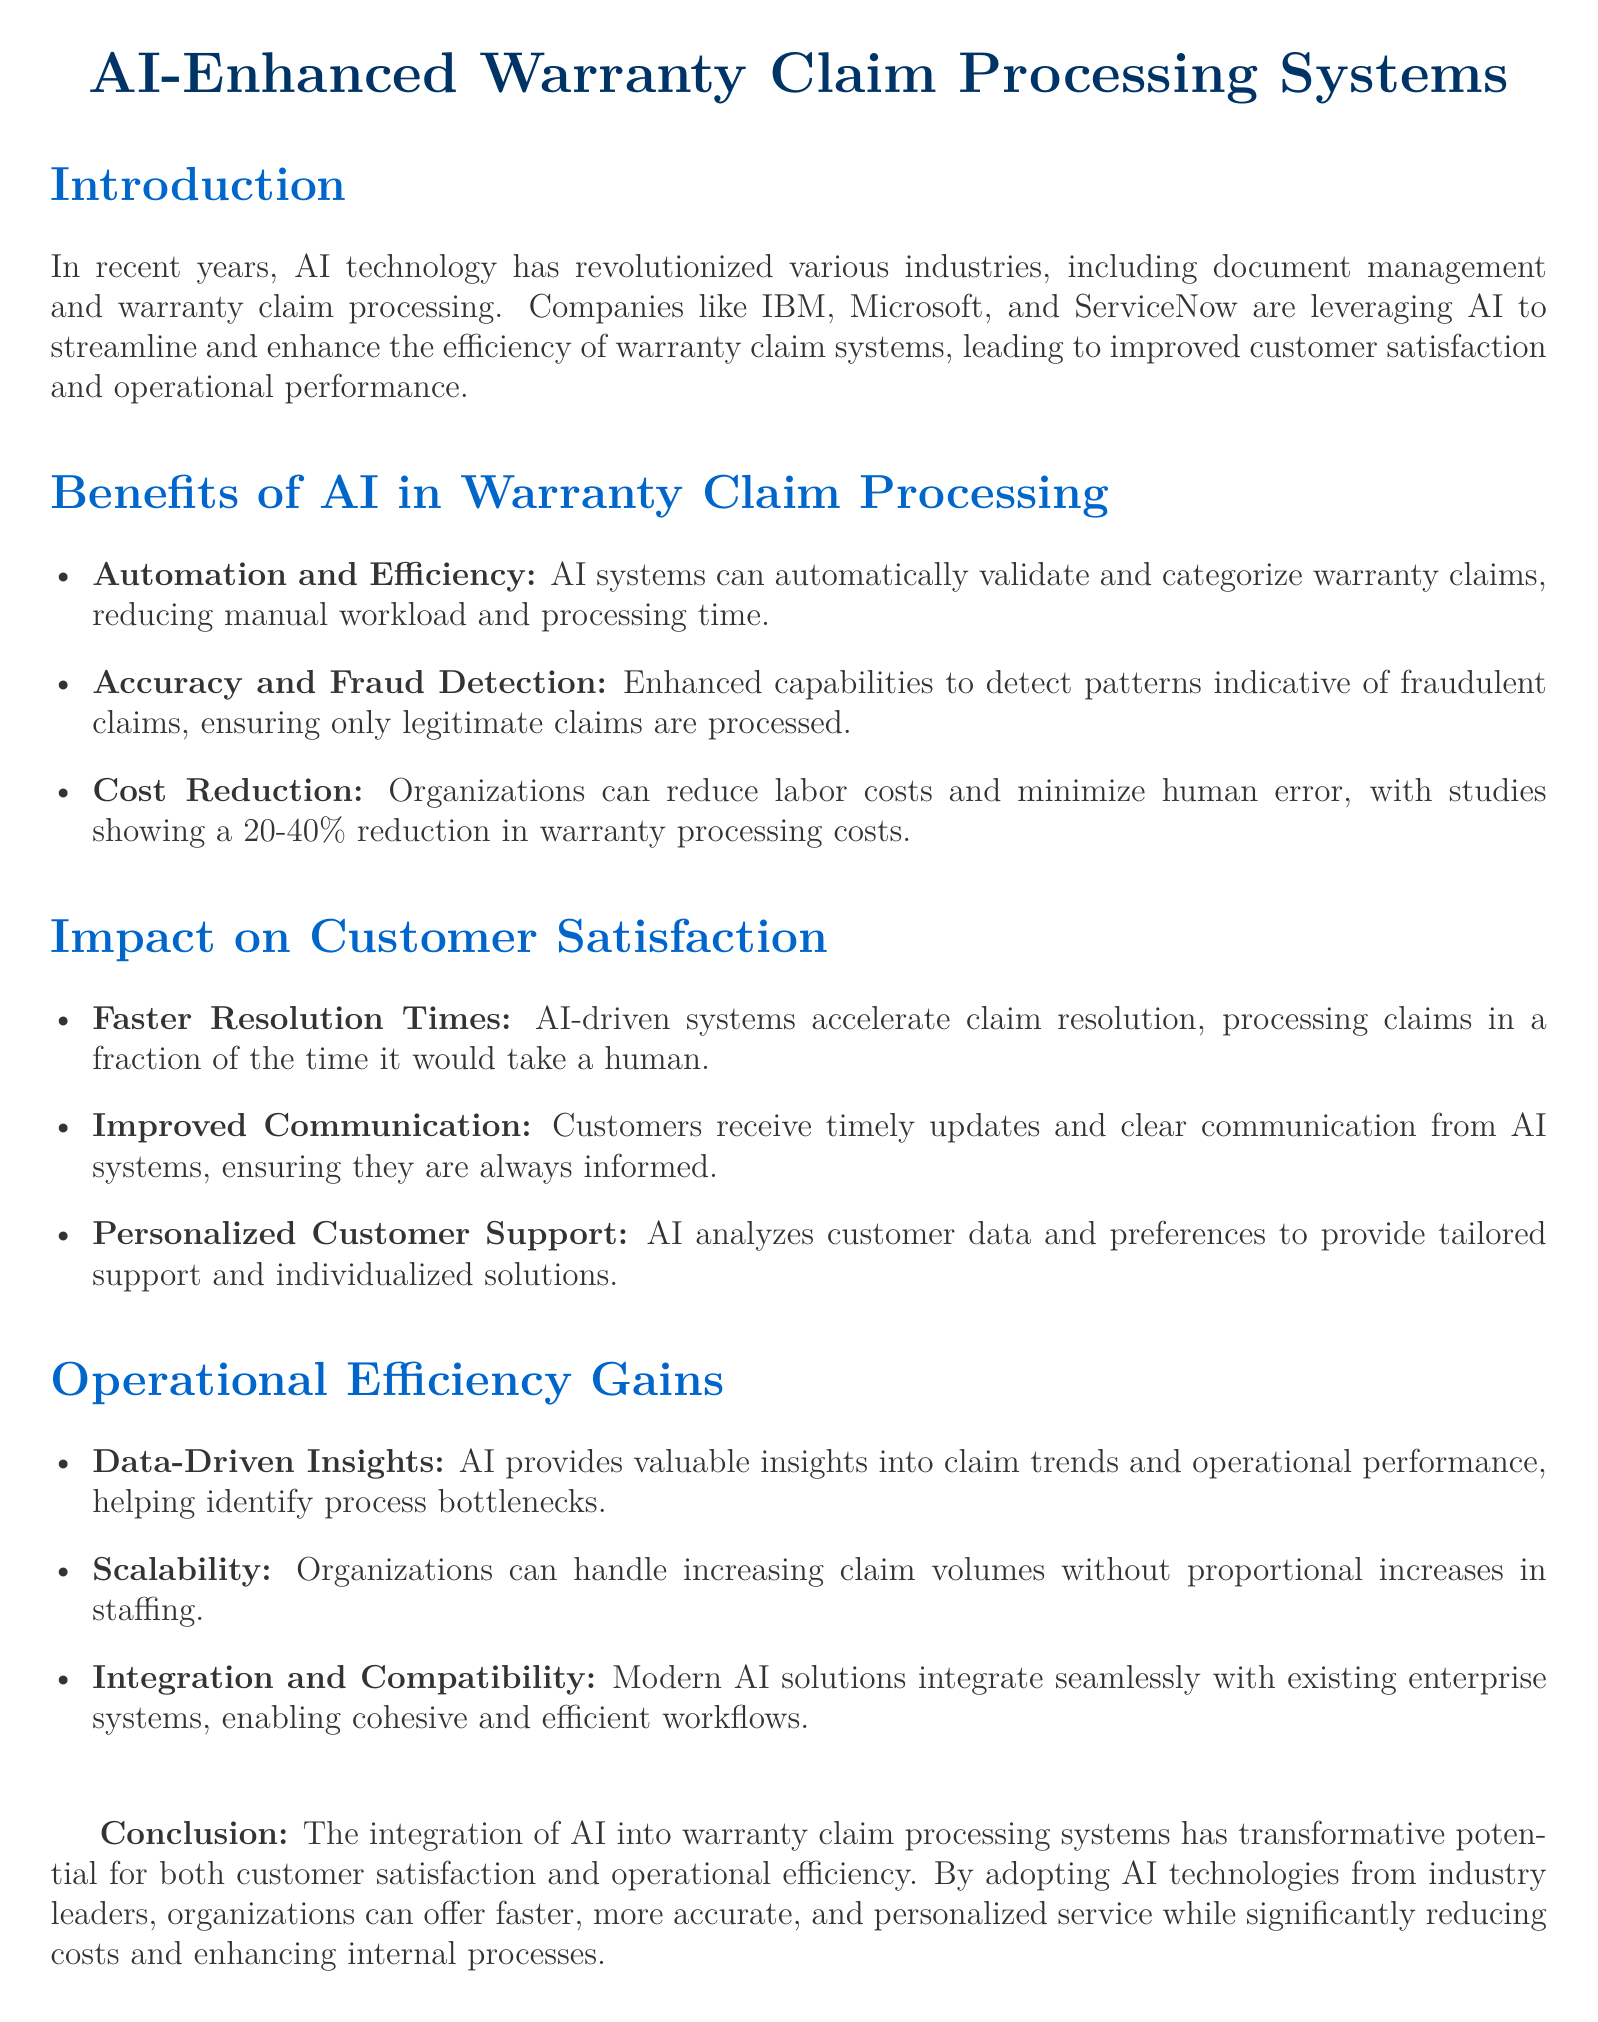What is the main technology discussed in this document? The document focuses on AI technology and its application in warranty claim processing systems.
Answer: AI technology Which companies are mentioned as leveraging AI in warranty systems? The document mentions IBM, Microsoft, and ServiceNow as companies using AI in warranty claim processing.
Answer: IBM, Microsoft, and ServiceNow What percentage reduction in warranty processing costs is noted? The document states that organizations can see a 20-40% reduction in warranty processing costs through AI integration.
Answer: 20-40% What benefit is associated with faster resolution times? The document explains that AI-driven systems lead to faster claim resolution and consequently better customer satisfaction.
Answer: Customer satisfaction What kind of insights does AI provide in warranty claim processing? According to the document, AI provides valuable data-driven insights into claim trends and operational performance.
Answer: Data-driven insights What aspect of customer communication is improved by AI systems? The document highlights that AI systems ensure timely updates and clear communication to the customers.
Answer: Timely updates Which feature makes AI systems scalable? The document indicates that organizations can manage increasing claim volumes without needing to proportionally increase staffing due to AI's efficiency.
Answer: Handles increasing claim volumes What is the document's conclusion about the integration of AI? The conclusion highlights that AI integration has transformative potential for customer satisfaction and operational efficiency in warranty claims.
Answer: Transformative potential 